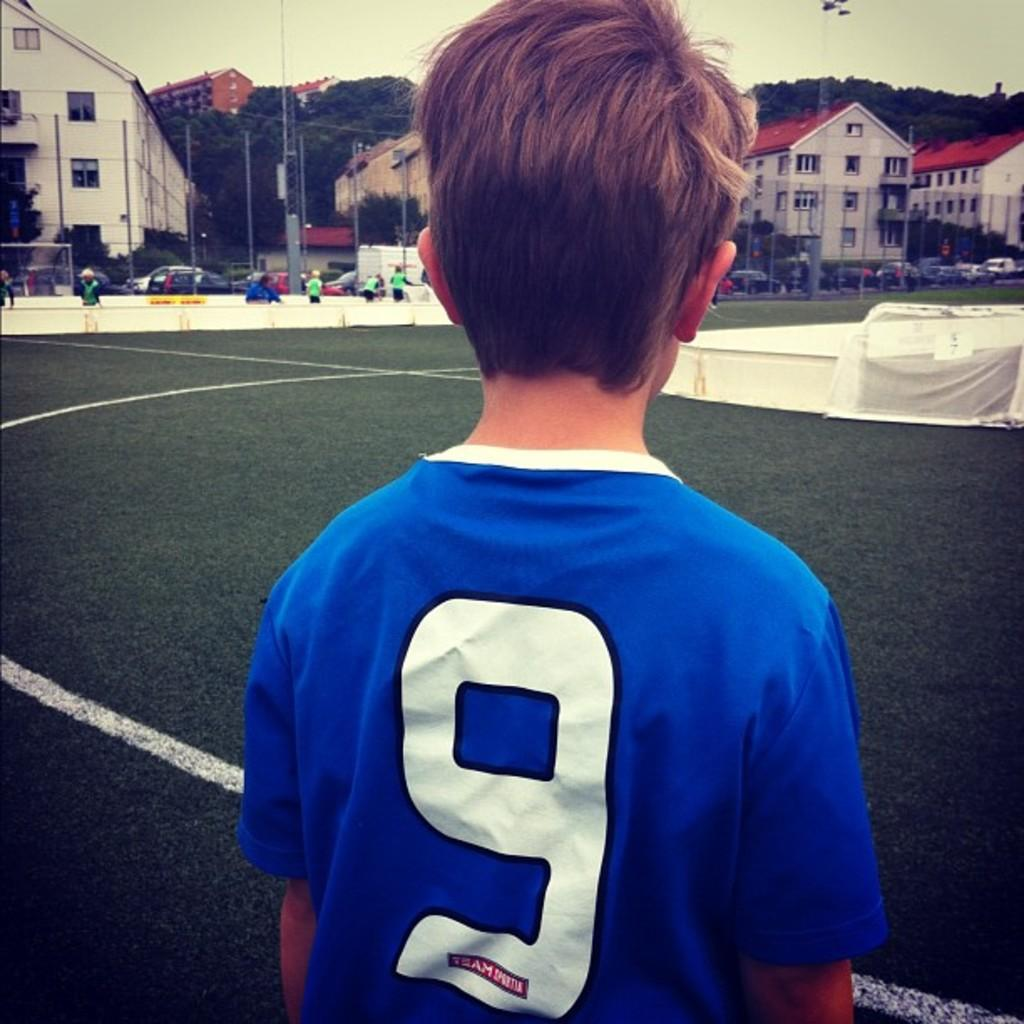<image>
Summarize the visual content of the image. A boy with a big 9 on the back of his shirt looks at a sports field. 